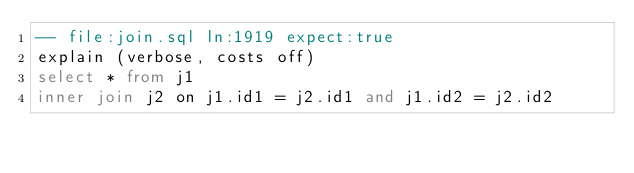Convert code to text. <code><loc_0><loc_0><loc_500><loc_500><_SQL_>-- file:join.sql ln:1919 expect:true
explain (verbose, costs off)
select * from j1
inner join j2 on j1.id1 = j2.id1 and j1.id2 = j2.id2
</code> 